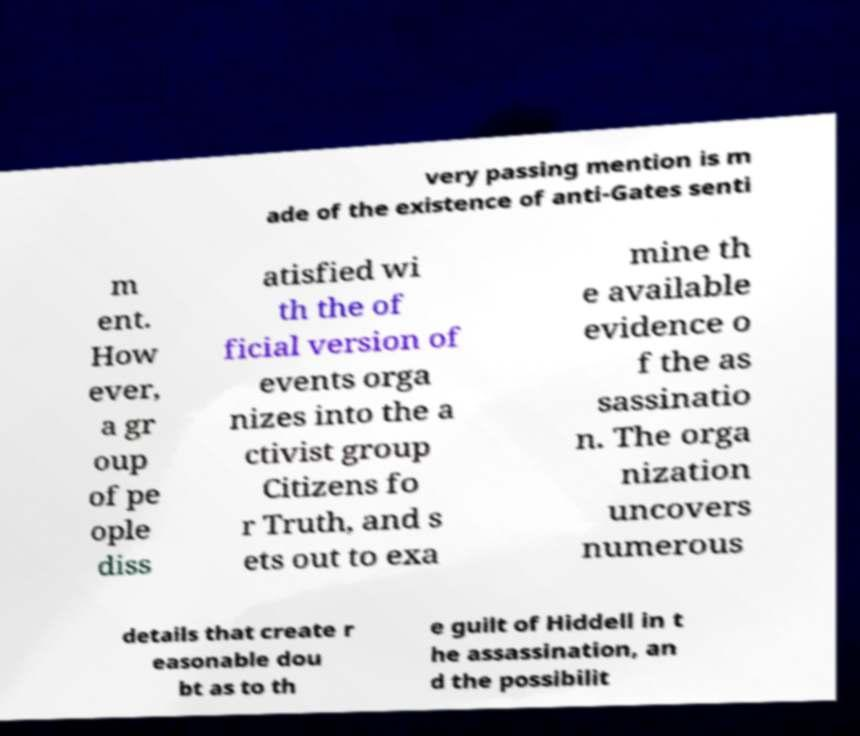For documentation purposes, I need the text within this image transcribed. Could you provide that? very passing mention is m ade of the existence of anti-Gates senti m ent. How ever, a gr oup of pe ople diss atisfied wi th the of ficial version of events orga nizes into the a ctivist group Citizens fo r Truth, and s ets out to exa mine th e available evidence o f the as sassinatio n. The orga nization uncovers numerous details that create r easonable dou bt as to th e guilt of Hiddell in t he assassination, an d the possibilit 